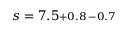<formula> <loc_0><loc_0><loc_500><loc_500>s = 7 . 5 \substack { + 0 . 8 \, - 0 . 7 }</formula> 